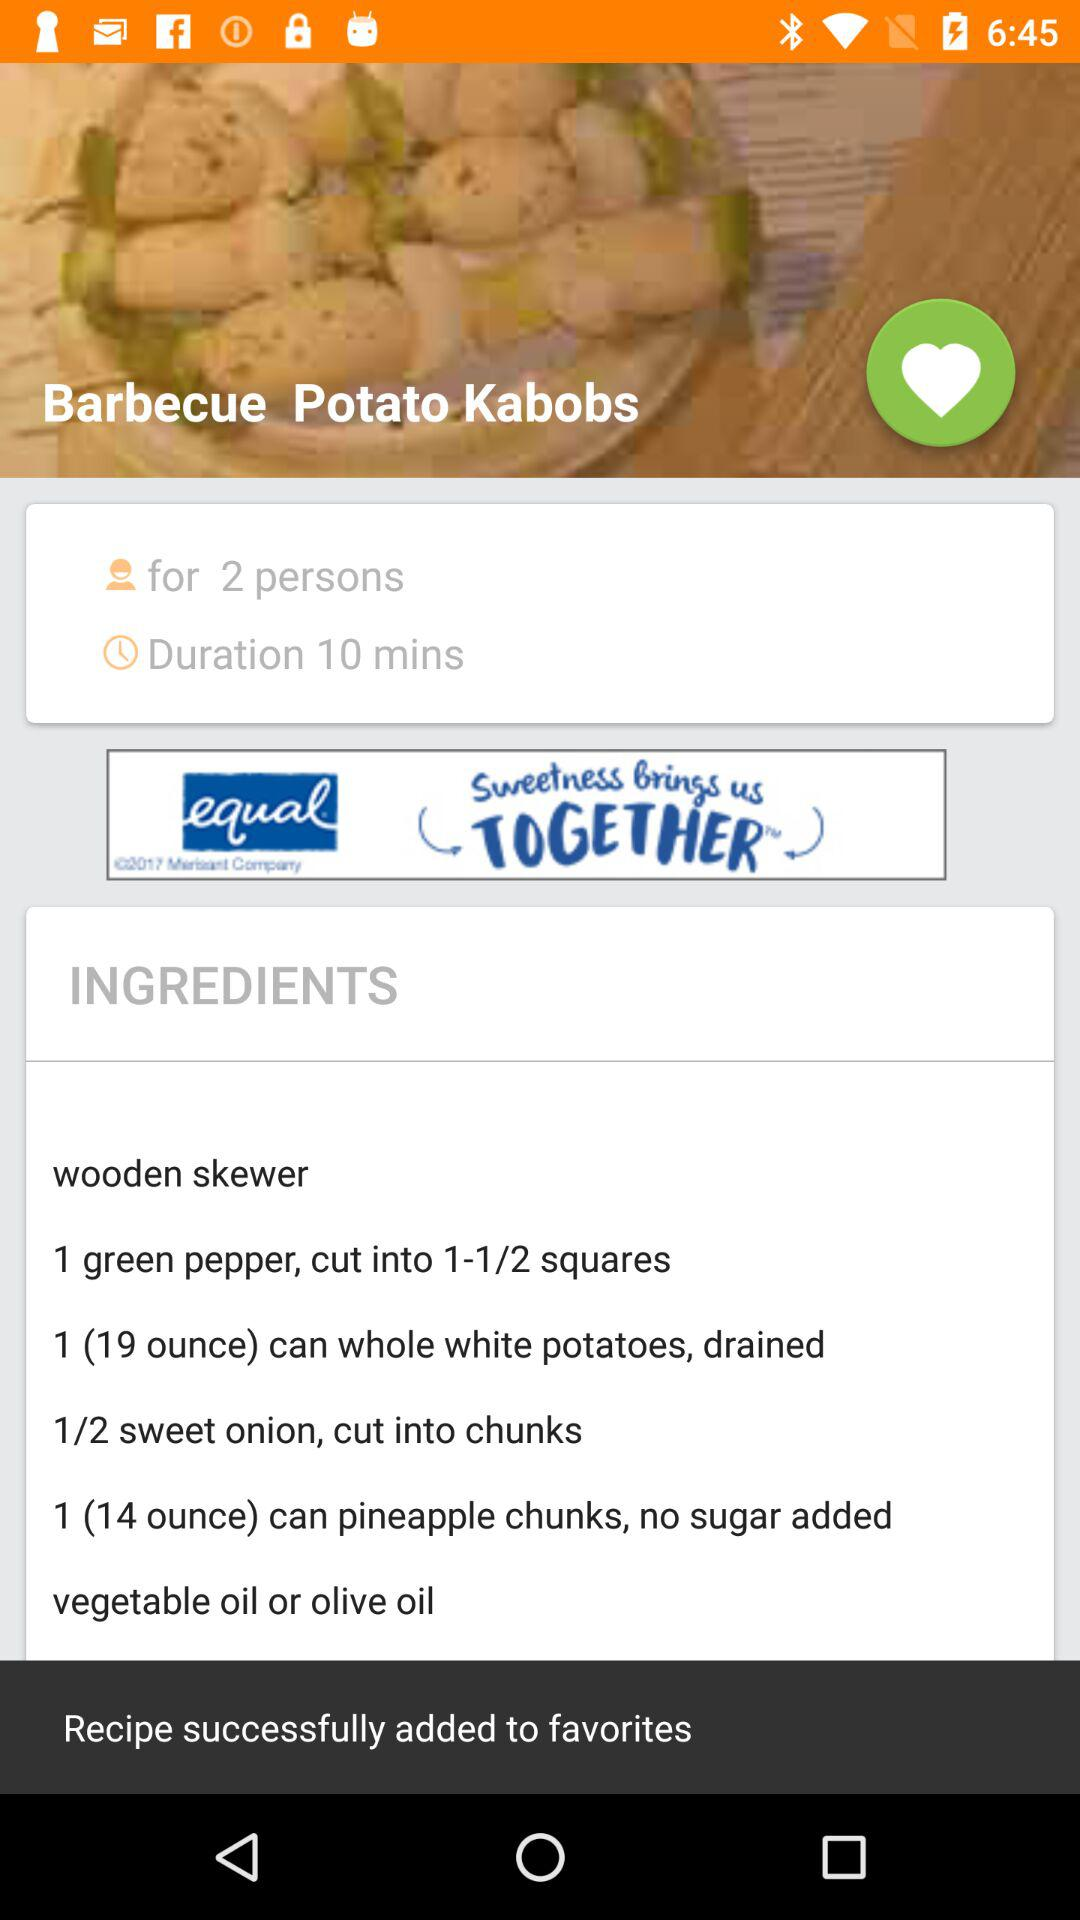How many green papers are required for "Barbecue Potato Kabobs"? For Barbecue Potato Kabobs, 1 green paper is required. 